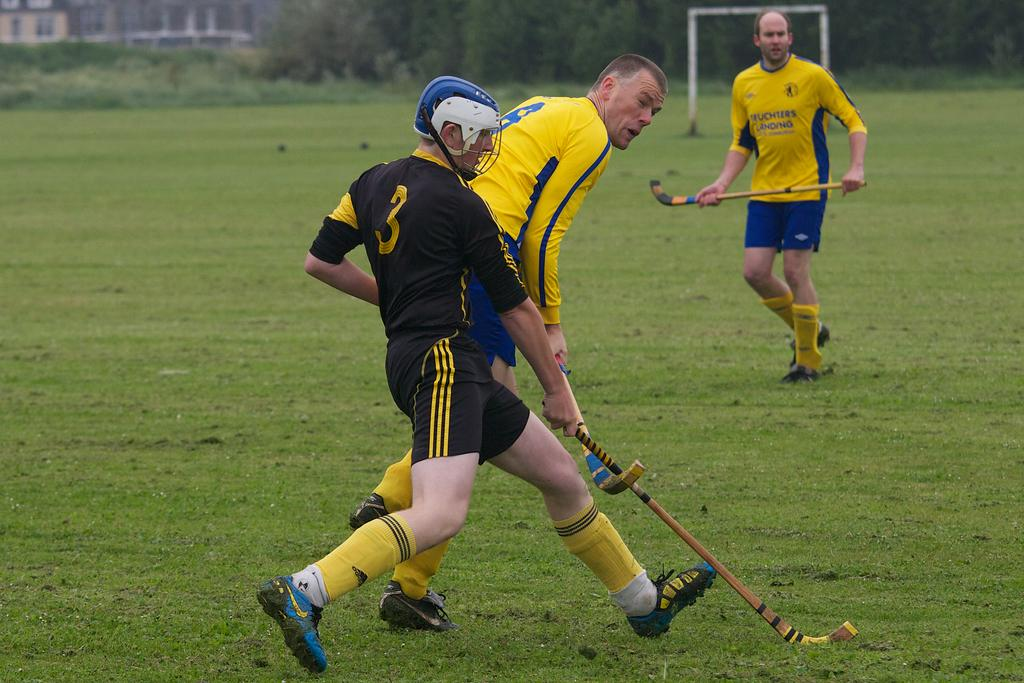<image>
Summarize the visual content of the image. two teams playing some game on a grass field, including black team 3 